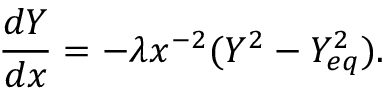<formula> <loc_0><loc_0><loc_500><loc_500>\frac { d Y } { d x } = - \lambda x ^ { - 2 } ( Y ^ { 2 } - Y _ { e q } ^ { 2 } ) .</formula> 